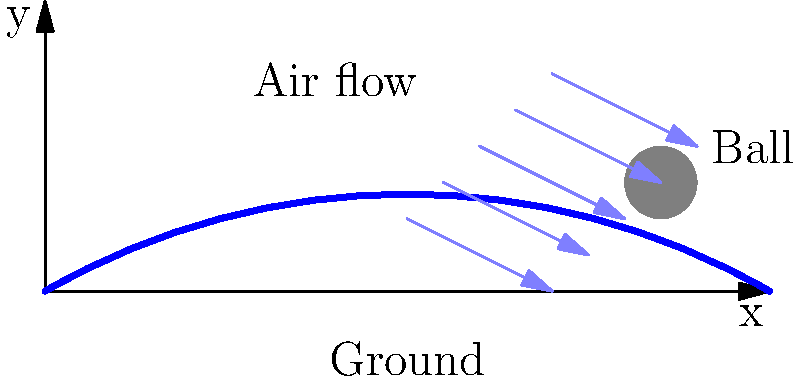Consider the trajectory of a soccer ball in flight as shown in the diagram. What principle explains the ball's curved path, and how does it relate to the air flow pattern around the ball? To understand the curved trajectory of a soccer ball in flight, we need to consider the Magnus effect:

1. Ball spin: When a soccer ball is kicked with spin, it rotates as it moves through the air.

2. Air flow difference: The spinning ball creates a difference in air speed on opposite sides of the ball.
   - On the side spinning in the same direction as the airflow, the air moves faster.
   - On the side spinning against the airflow, the air moves slower.

3. Pressure difference: According to Bernoulli's principle, faster-moving air has lower pressure than slower-moving air.
   - Lower pressure on the side with faster airflow
   - Higher pressure on the side with slower airflow

4. Lateral force: The pressure difference creates a force perpendicular to the direction of motion, known as the Magnus force.

5. Curved trajectory: This lateral force causes the ball to deviate from a straight path, resulting in a curved trajectory.

6. Air flow visualization: In the diagram, the air flow lines show how the air moves around the ball, with a concentration of flow lines on one side, indicating the area of lower pressure.

The magnitude of this effect depends on factors such as:
- The ball's spin rate
- Its velocity
- Air density
- The ball's surface characteristics

Understanding this principle is crucial for players to control the ball's flight path, allowing for techniques like bending free kicks or curving corner kicks.
Answer: Magnus effect 